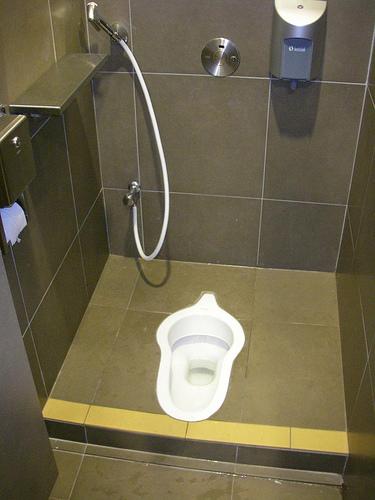Is this a sink?
Answer briefly. No. Is the pictured object a bidet?
Answer briefly. No. What kind of room is this?
Give a very brief answer. Bathroom. 